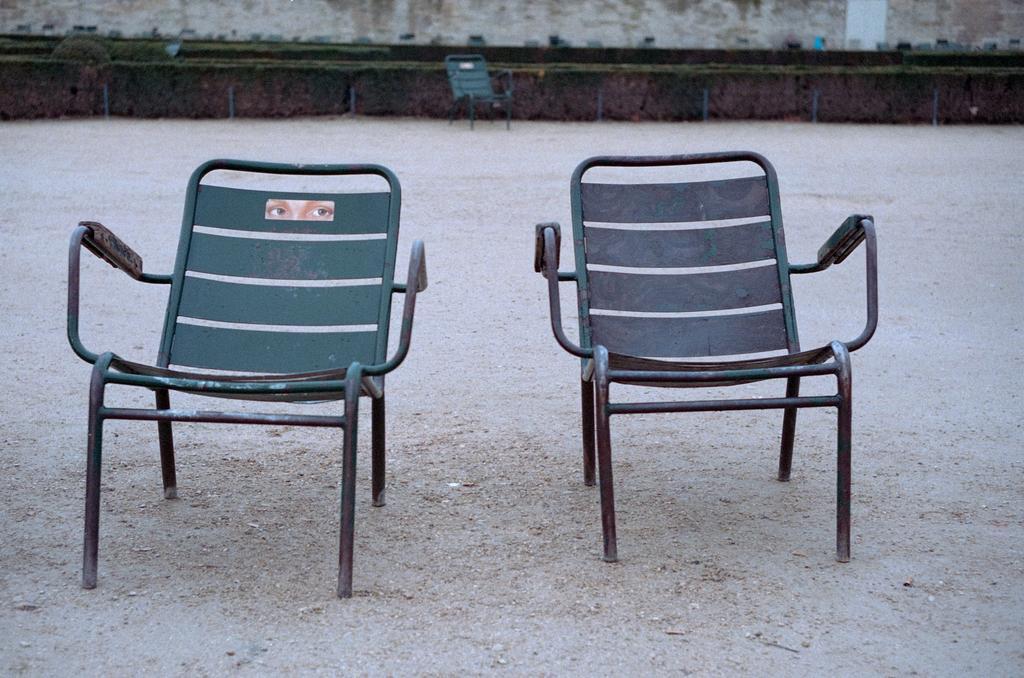Describe this image in one or two sentences. In this image I can see two chairs, they are in green color. Background I can see the other chair and I can see grass and trees in green color. 